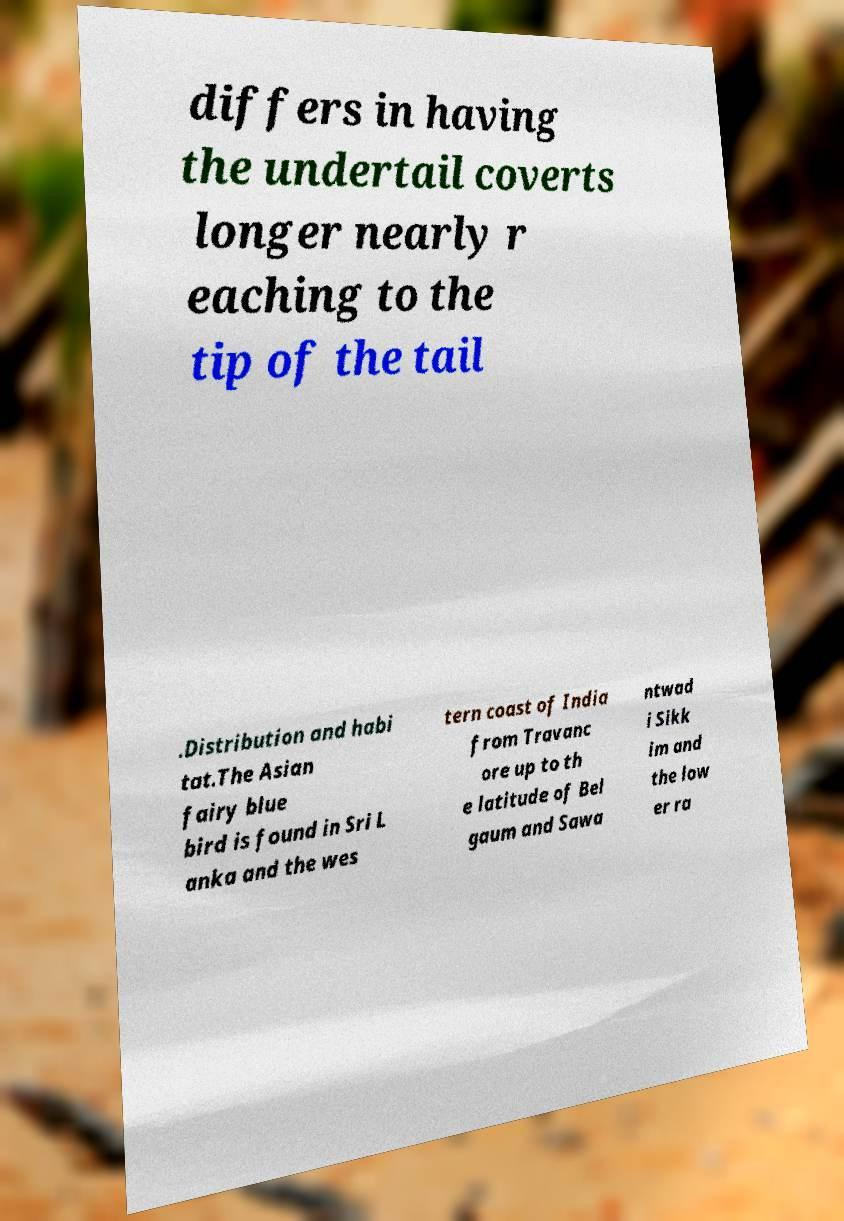What messages or text are displayed in this image? I need them in a readable, typed format. differs in having the undertail coverts longer nearly r eaching to the tip of the tail .Distribution and habi tat.The Asian fairy blue bird is found in Sri L anka and the wes tern coast of India from Travanc ore up to th e latitude of Bel gaum and Sawa ntwad i Sikk im and the low er ra 